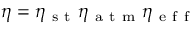<formula> <loc_0><loc_0><loc_500><loc_500>\eta = \eta _ { s t } \eta _ { a t m } \eta _ { e f f }</formula> 